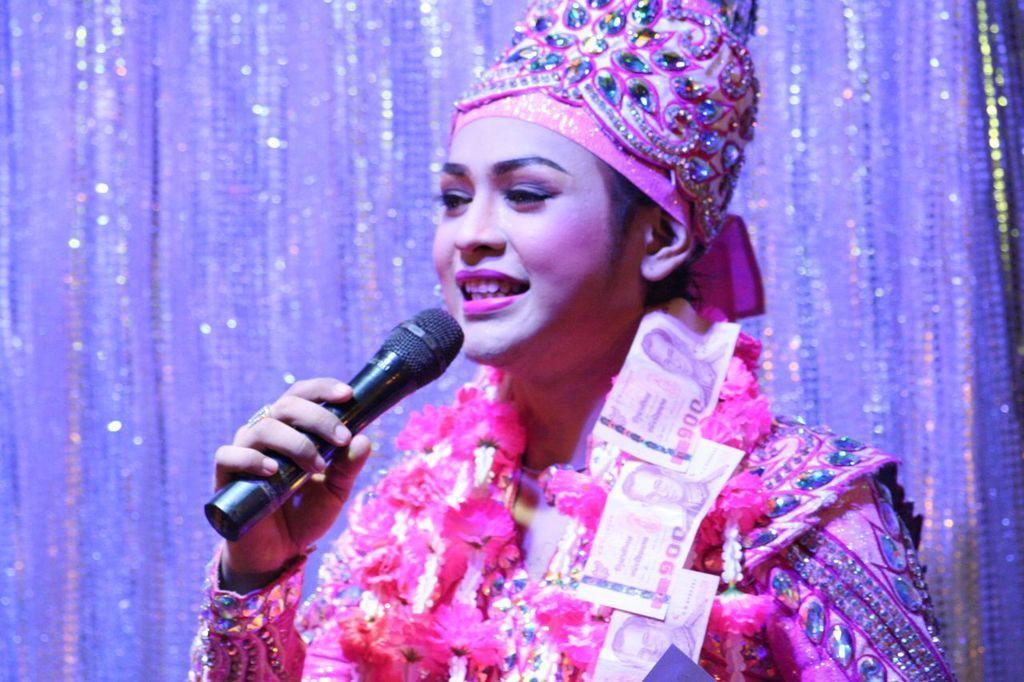Please provide a concise description of this image. In this picture there is the woman standing and speaking and she is holding a microphone in her hand 